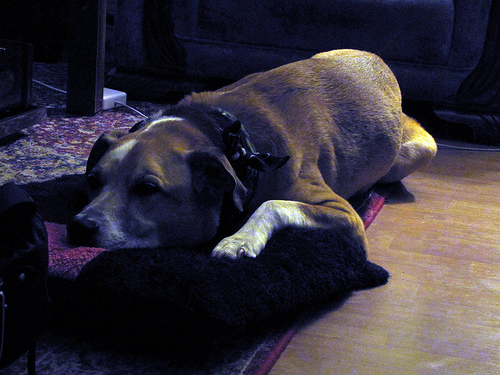<image>
Can you confirm if the dog is above the bow? No. The dog is not positioned above the bow. The vertical arrangement shows a different relationship. Where is the dog in relation to the floor? Is it on the floor? Yes. Looking at the image, I can see the dog is positioned on top of the floor, with the floor providing support. 